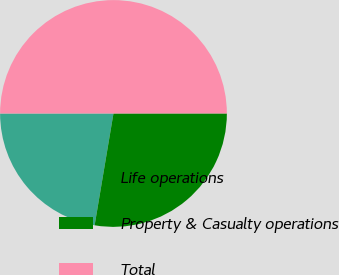Convert chart to OTSL. <chart><loc_0><loc_0><loc_500><loc_500><pie_chart><fcel>Life operations<fcel>Property & Casualty operations<fcel>Total<nl><fcel>22.34%<fcel>27.66%<fcel>50.0%<nl></chart> 